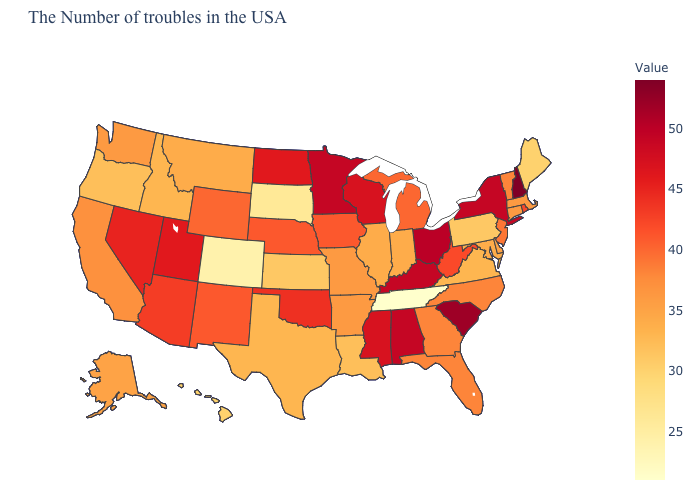Among the states that border Nebraska , does Iowa have the highest value?
Write a very short answer. Yes. Among the states that border Maryland , which have the lowest value?
Write a very short answer. Pennsylvania. Does Tennessee have the lowest value in the USA?
Keep it brief. Yes. Does the map have missing data?
Concise answer only. No. Among the states that border New Hampshire , does Maine have the lowest value?
Keep it brief. Yes. Among the states that border California , does Oregon have the highest value?
Keep it brief. No. Does New Hampshire have the highest value in the USA?
Concise answer only. Yes. Does New Hampshire have the highest value in the USA?
Quick response, please. Yes. 